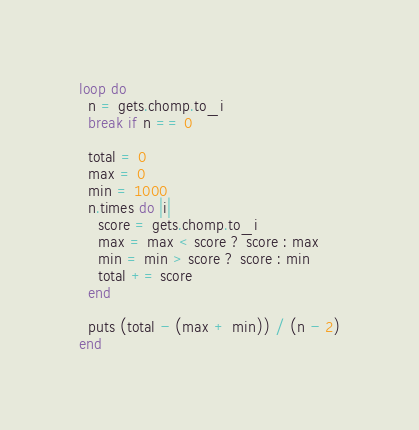Convert code to text. <code><loc_0><loc_0><loc_500><loc_500><_Ruby_>loop do
  n = gets.chomp.to_i
  break if n == 0

  total = 0
  max = 0
  min = 1000
  n.times do |i|
    score = gets.chomp.to_i
    max = max < score ? score : max
    min = min > score ? score : min
    total += score
  end

  puts (total - (max + min)) / (n - 2)
end</code> 